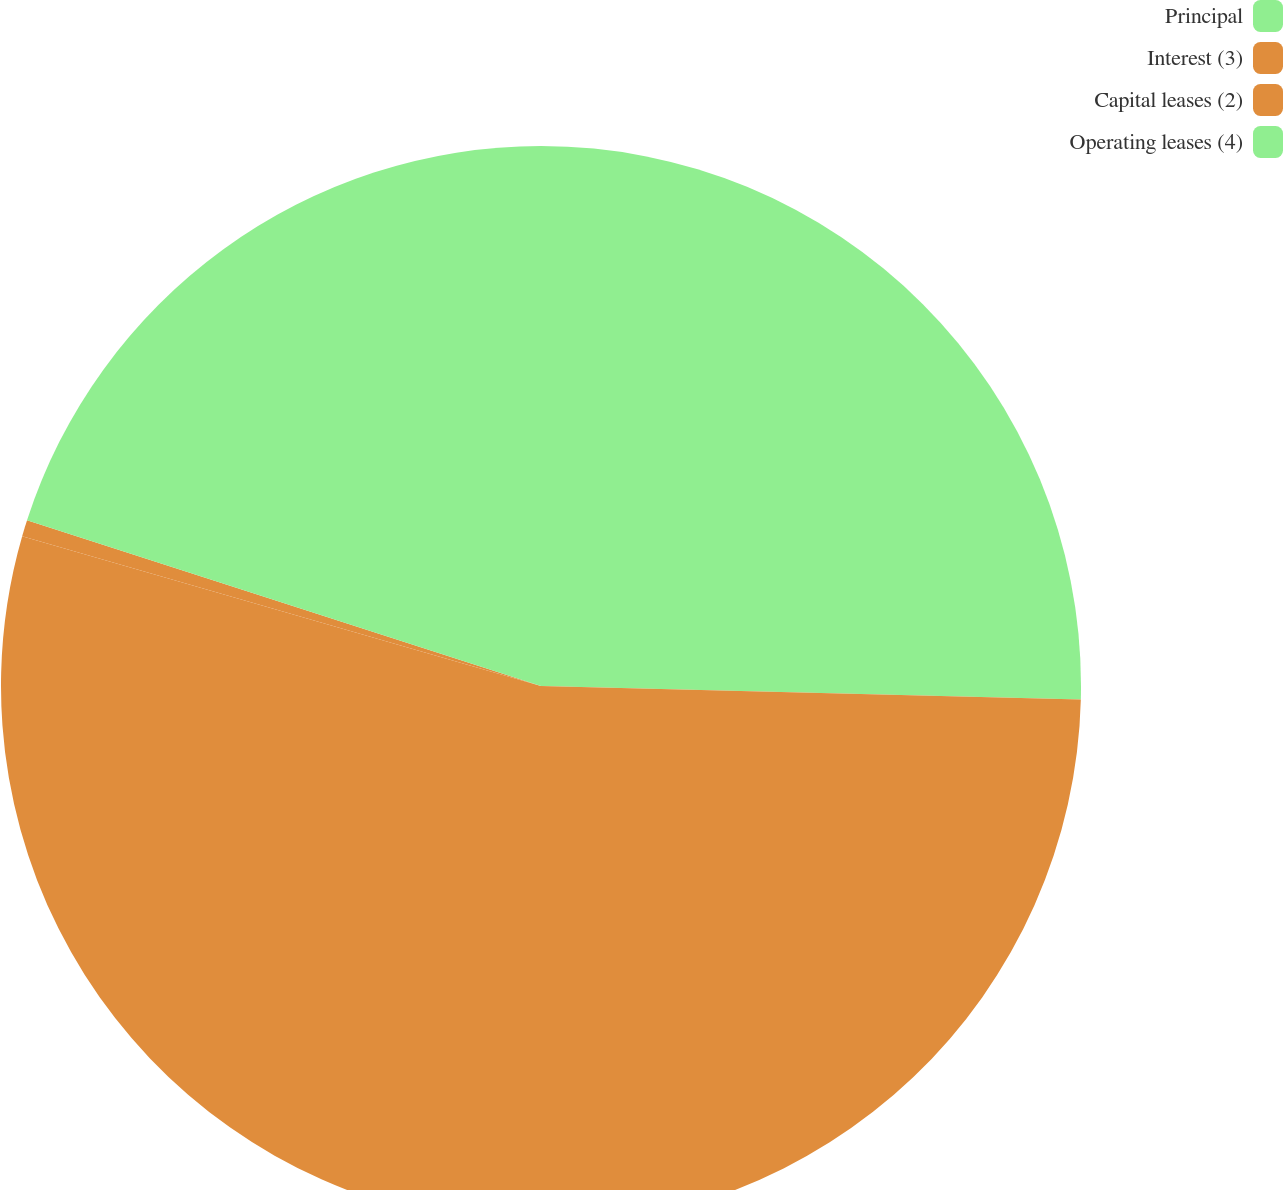Convert chart. <chart><loc_0><loc_0><loc_500><loc_500><pie_chart><fcel>Principal<fcel>Interest (3)<fcel>Capital leases (2)<fcel>Operating leases (4)<nl><fcel>25.4%<fcel>54.08%<fcel>0.49%<fcel>20.04%<nl></chart> 